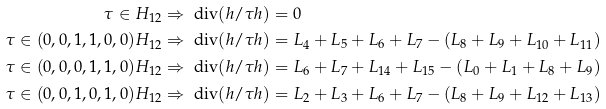<formula> <loc_0><loc_0><loc_500><loc_500>\tau \in H _ { 1 2 } & \Rightarrow \ \text {div} ( h / \tau h ) = 0 \\ \tau \in ( 0 , 0 , 1 , 1 , 0 , 0 ) H _ { 1 2 } & \Rightarrow \ \text {div} ( h / \tau h ) = L _ { 4 } + L _ { 5 } + L _ { 6 } + L _ { 7 } - ( L _ { 8 } + L _ { 9 } + L _ { 1 0 } + L _ { 1 1 } ) \\ \tau \in ( 0 , 0 , 0 , 1 , 1 , 0 ) H _ { 1 2 } & \Rightarrow \ \text {div} ( h / \tau h ) = L _ { 6 } + L _ { 7 } + L _ { 1 4 } + L _ { 1 5 } - ( L _ { 0 } + L _ { 1 } + L _ { 8 } + L _ { 9 } ) \\ \tau \in ( 0 , 0 , 1 , 0 , 1 , 0 ) H _ { 1 2 } & \Rightarrow \ \text {div} ( h / \tau h ) = L _ { 2 } + L _ { 3 } + L _ { 6 } + L _ { 7 } - ( L _ { 8 } + L _ { 9 } + L _ { 1 2 } + L _ { 1 3 } )</formula> 